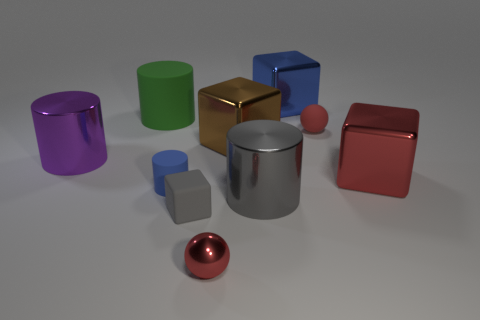Is the color of the matte sphere the same as the shiny sphere?
Give a very brief answer. Yes. How many rubber objects are big balls or red spheres?
Offer a very short reply. 1. What number of small cylinders are there?
Offer a terse response. 1. Do the small red thing behind the purple metal cylinder and the large block in front of the brown metallic object have the same material?
Ensure brevity in your answer.  No. What color is the other matte thing that is the same shape as the big blue thing?
Offer a very short reply. Gray. There is a ball that is to the left of the big metallic cylinder that is on the right side of the large green thing; what is it made of?
Your answer should be very brief. Metal. There is a metal object behind the big rubber cylinder; is it the same shape as the big brown metallic thing in front of the green object?
Your response must be concise. Yes. What size is the metal thing that is to the left of the brown metal object and right of the big green thing?
Give a very brief answer. Small. How many other objects are the same color as the small cylinder?
Ensure brevity in your answer.  1. Is the material of the block on the right side of the large blue object the same as the big gray cylinder?
Provide a short and direct response. Yes. 